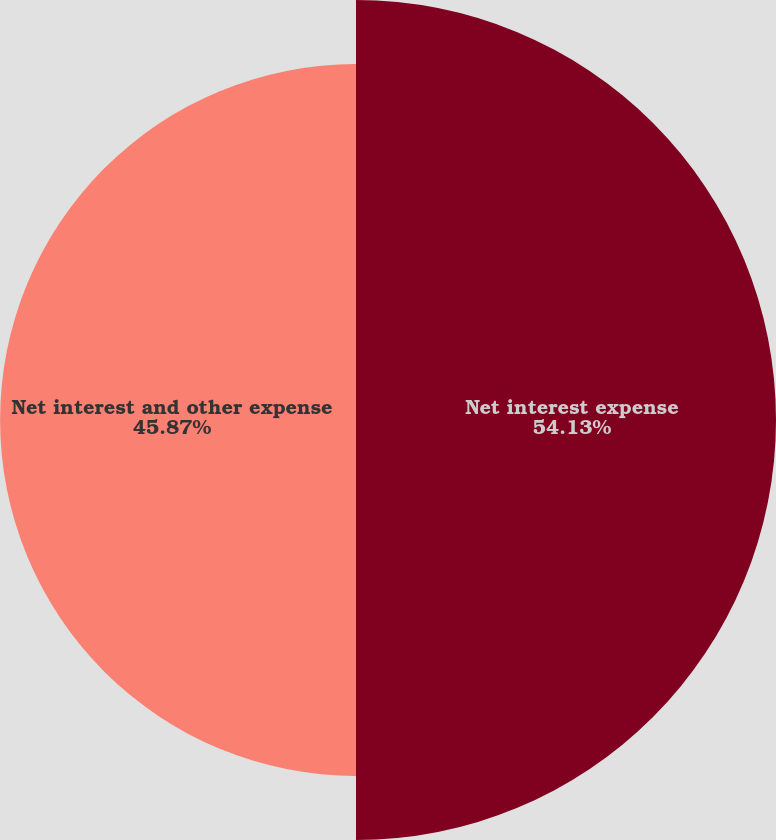Convert chart to OTSL. <chart><loc_0><loc_0><loc_500><loc_500><pie_chart><fcel>Net interest expense<fcel>Net interest and other expense<nl><fcel>54.13%<fcel>45.87%<nl></chart> 